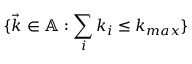Convert formula to latex. <formula><loc_0><loc_0><loc_500><loc_500>\{ \ V e c { k } \in \mathbb { A } \colon \sum _ { i } k _ { i } \leq k _ { \max } \}</formula> 